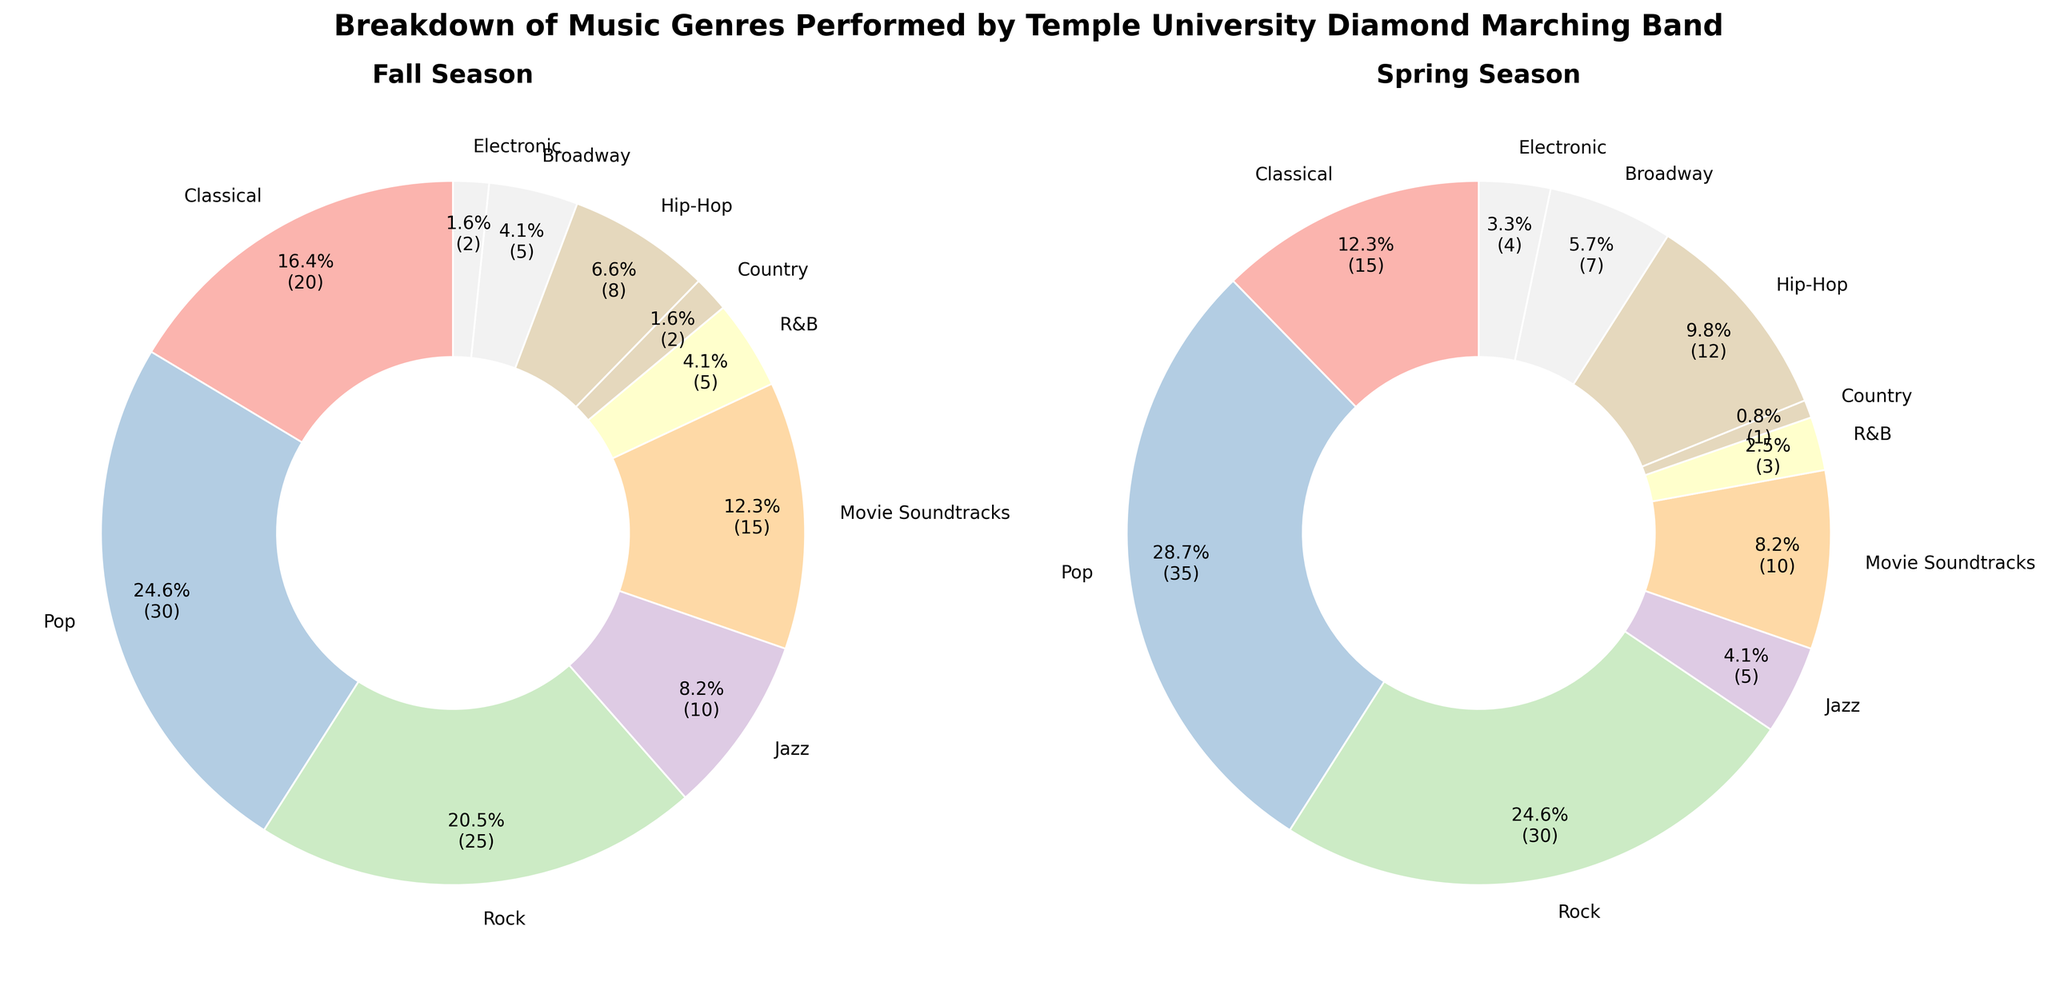How many more Pop performances are there compared to Jazz performances in the Fall Season? In the Fall Season, Pop has 30 performances and Jazz has 10. Subtracting these values, 30 - 10 = 20
Answer: 20 Which genre has the smallest number of performances in the Spring Season? The data shows that Country has the smallest number of performances, which is 1 in the Spring Season
Answer: Country What is the combined number of Classical and Rock performances in the Fall Season? In the Fall Season, Classical has 20 performances and Rock has 25. Adding these values, 20 + 25 = 45
Answer: 45 Which season had a higher number of Electronic performances and by how much? In the Fall Season, there are 2 Electronic performances and in the Spring Season, there are 4. The Spring Season has 4 - 2 = 2 more Electronic performances
Answer: Spring Season, by 2 Which genre shows the most significant increase in the number of performances from Fall to Spring? Comparing the numbers, Hip-Hop increases from 8 in the Fall to 12 in the Spring. The increase is 12 - 8 = 4
Answer: Hip-Hop, by 4 Are there more Rock or Jazz performances in the Spring Season? In the Spring Season, Rock has 30 performances, and Jazz has 5. Therefore, Rock has more performances
Answer: Rock What is the proportional difference in the percentage of Pop performances between Fall and Spring? Using the pie charts, Pop's percentage in the Fall is calculated by (30/117) * 100 ≈ 25.6%, and in the Spring it is (35/122) * 100 ≈ 28.7%. The difference is 28.7% - 25.6% = 3.1% increase
Answer: 3.1% increase What genres have the same number of performances in the Fall Season? In the Fall Season, R&B and Broadway both have 5 performances
Answer: R&B and Broadway By how many performances does Movie Soundtracks exceed Electronic in the Fall Season? In the Fall Season, Movie Soundtracks has 15 performances and Electronic has 2. The excess is 15 - 2 = 13
Answer: 13 How do the colors used help distinguish the different genres in the pie charts? Each genre is represented by different colors, allowing for easy distinction between the genres in both the Fall and Spring Seasons
Answer: Different colors per genre Which genre collectively has 12 performances over both seasons? Adding performances across both seasons, R&B has 5 (Fall) + 3 (Spring) = 8, Hip-Hop has 8 (Fall) + 12 (Spring) = 20. Only Electronic has 2 (Fall) + 4 (Spring) = 6 and Country has 2 (Fall) + 1 (Spring) = 3. Therefore no genre collectively sums to 12
Answer: None 